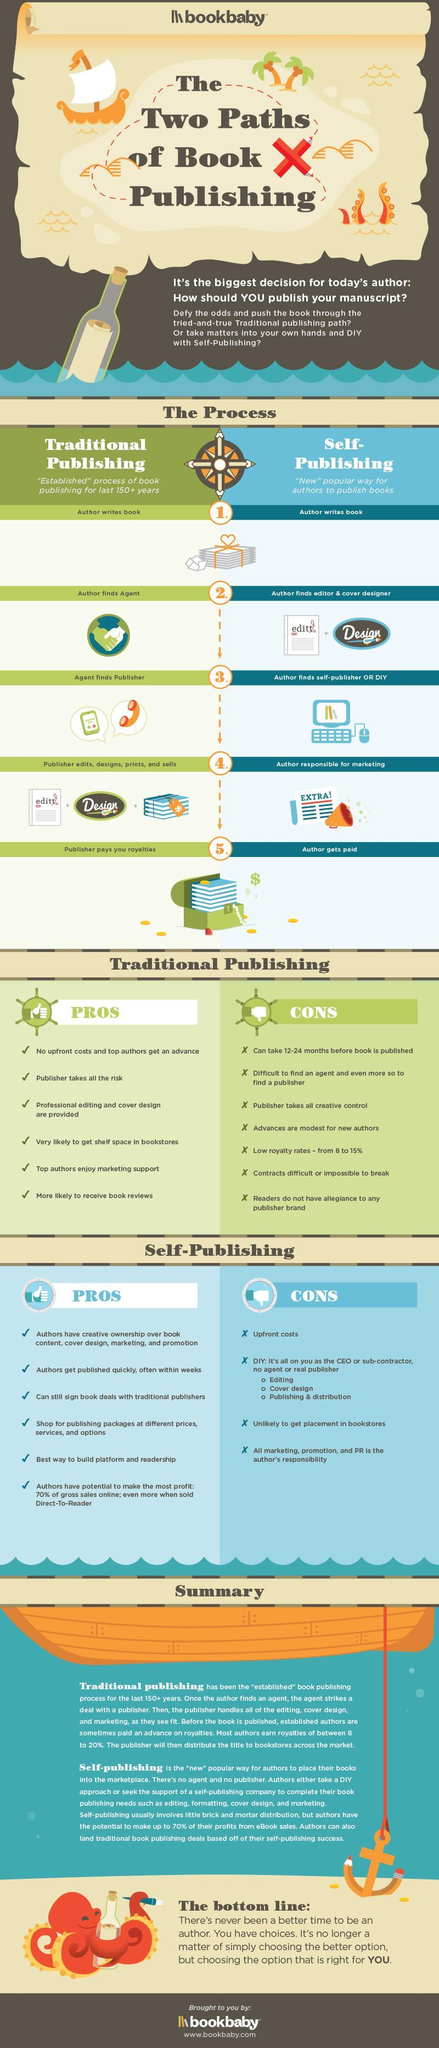what is the colour of the sail of the boat, white or orange
Answer the question with a short phrase. white what publishing process is best if you want the book published quickly self-publishing In which process does Agent find publisher traditional publishing In which publishing does the author get royalties traditional publishing in which publishing process is the risk on the publisher traditional publishing what is step 1 of both traditional publishing and self publishing author writes book what are the 2 process in publishing traditional publishing, self-publishing Which type of publishing can the author be more creative self-publishing Who does the marketing in self-publishing author 